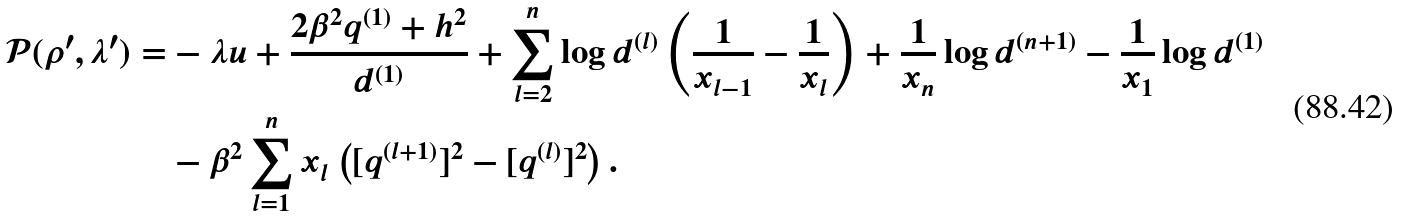<formula> <loc_0><loc_0><loc_500><loc_500>\mathcal { P } ( \rho ^ { \prime } , \lambda ^ { \prime } ) = & - \lambda u + \frac { 2 \beta ^ { 2 } q ^ { ( 1 ) } + h ^ { 2 } } { d ^ { ( 1 ) } } + \sum _ { l = 2 } ^ { n } \log d ^ { ( l ) } \left ( \frac { 1 } { x _ { l - 1 } } - \frac { 1 } { x _ { l } } \right ) + \frac { 1 } { x _ { n } } \log d ^ { ( n + 1 ) } - \frac { 1 } { x _ { 1 } } \log d ^ { ( 1 ) } \\ & - \beta ^ { 2 } \sum _ { l = 1 } ^ { n } x _ { l } \left ( [ q ^ { ( l + 1 ) } ] ^ { 2 } - [ q ^ { ( l ) } ] ^ { 2 } \right ) .</formula> 